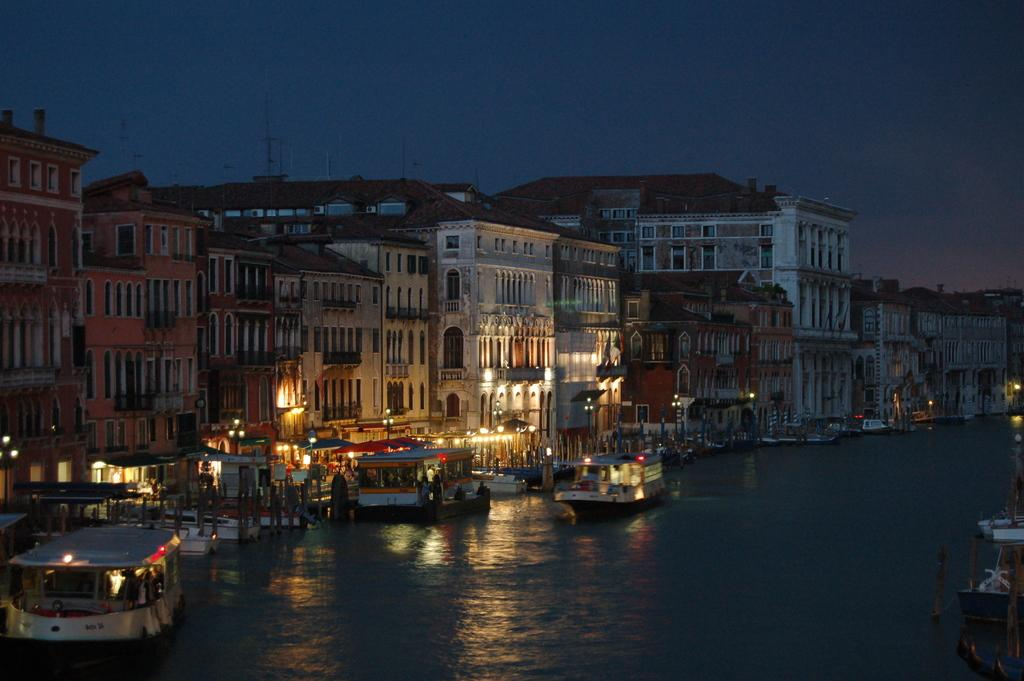What is happening in the image? There are ships sailing in the image. Where are the ships located? The ships are on the water. What can be seen in the background of the image? There are buildings in the background of the image. What else is visible in the image? There are lights visible in the image. How does the quilt contribute to the image? There is no quilt present in the image. 